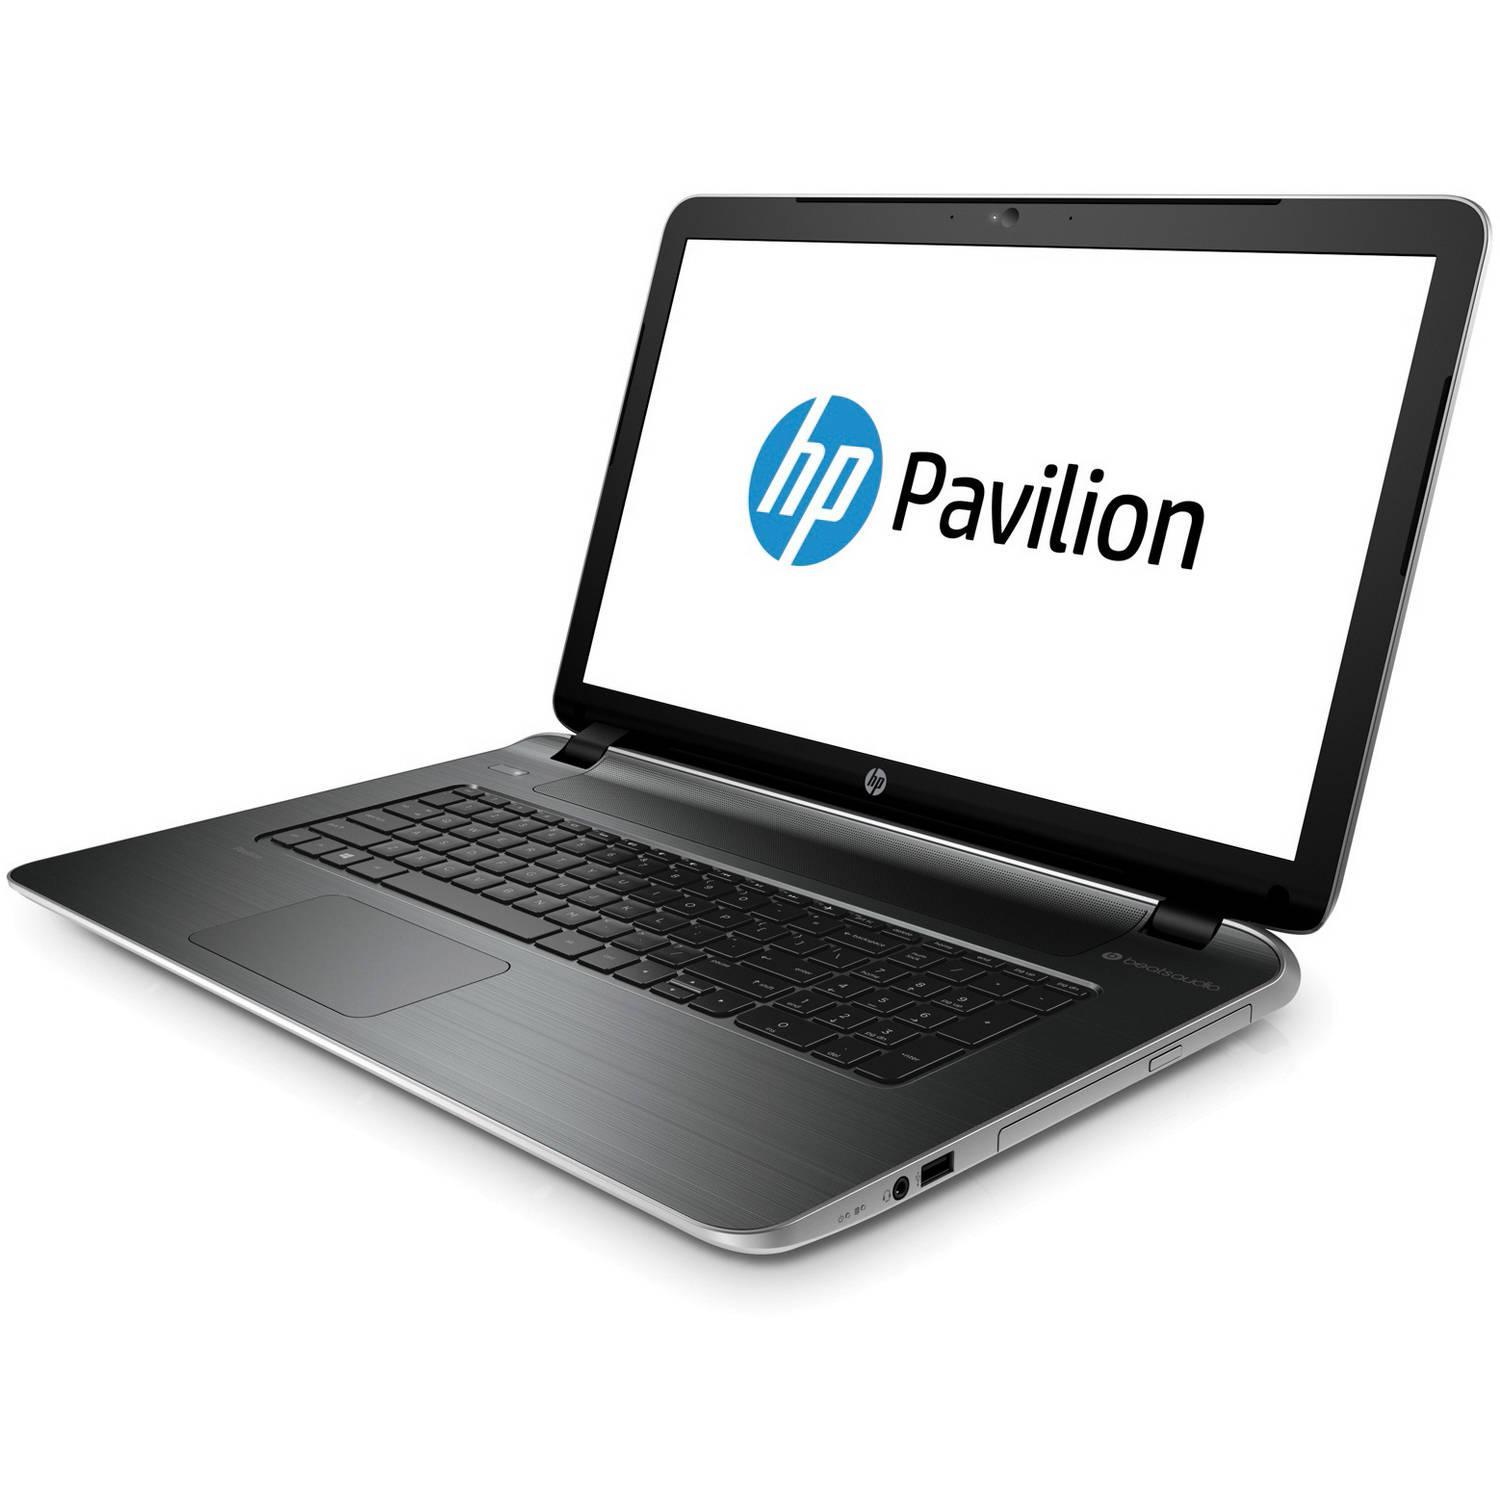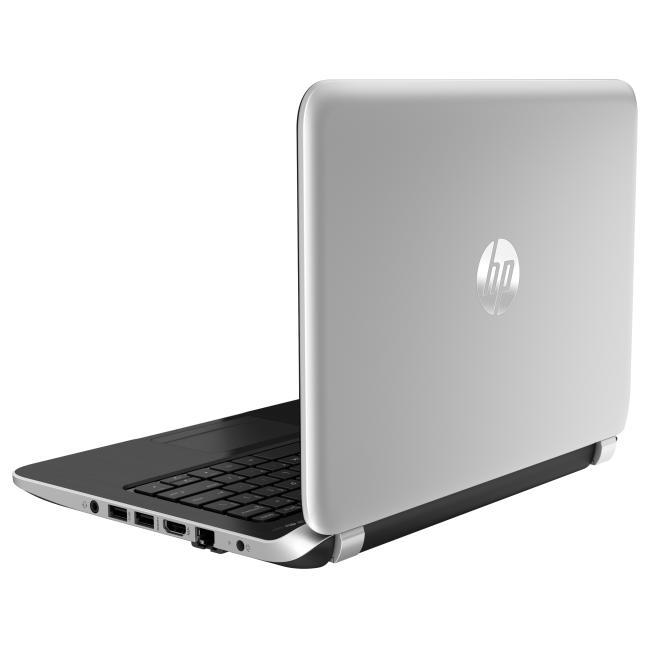The first image is the image on the left, the second image is the image on the right. Given the left and right images, does the statement "One laptop is facing directly forward, and another laptop is facing diagonally backward." hold true? Answer yes or no. No. The first image is the image on the left, the second image is the image on the right. Assess this claim about the two images: "One open laptop is displayed head-on, and the other open laptop is displayed at an angle with its screen facing away from the camera toward the left.". Correct or not? Answer yes or no. No. 